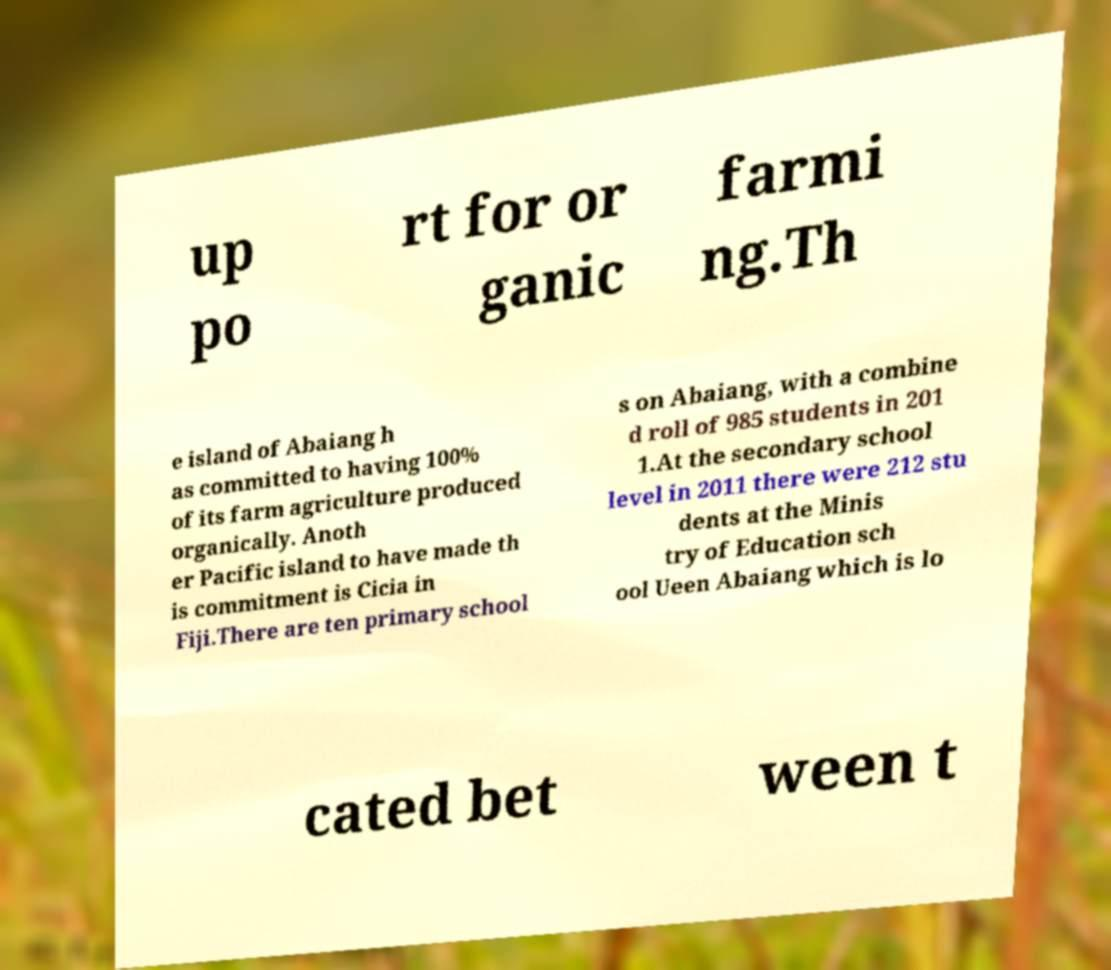I need the written content from this picture converted into text. Can you do that? up po rt for or ganic farmi ng.Th e island of Abaiang h as committed to having 100% of its farm agriculture produced organically. Anoth er Pacific island to have made th is commitment is Cicia in Fiji.There are ten primary school s on Abaiang, with a combine d roll of 985 students in 201 1.At the secondary school level in 2011 there were 212 stu dents at the Minis try of Education sch ool Ueen Abaiang which is lo cated bet ween t 